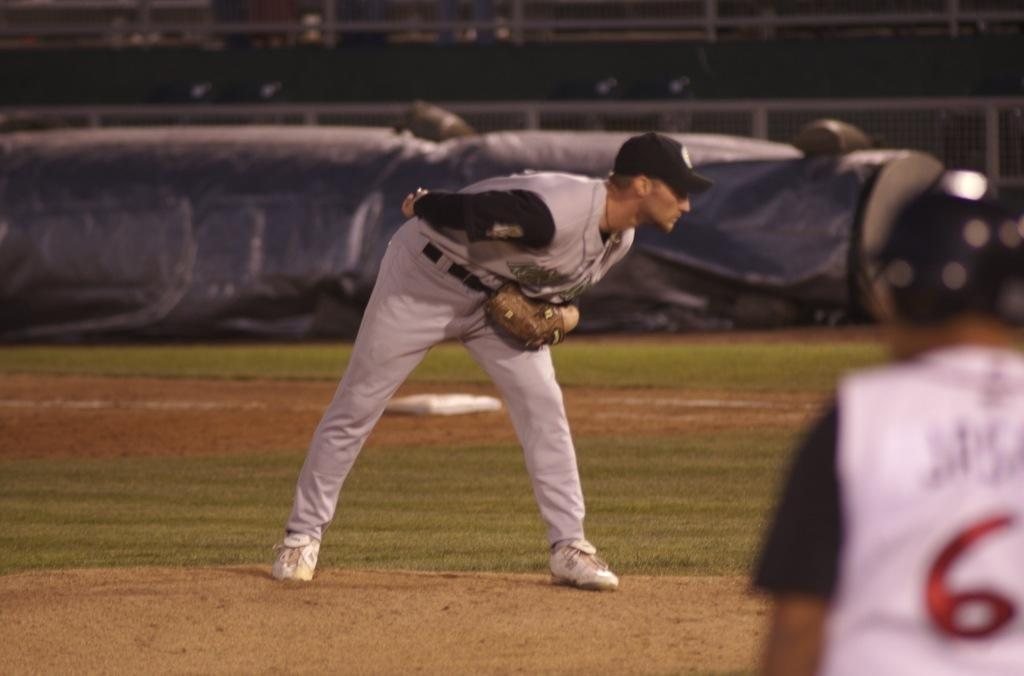<image>
Describe the image concisely. Player 6 anxiously awaited a chance to steal home. 